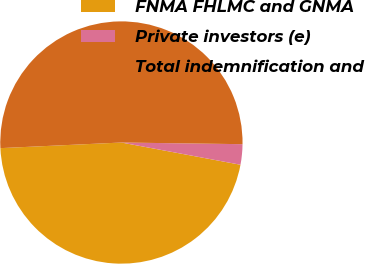Convert chart. <chart><loc_0><loc_0><loc_500><loc_500><pie_chart><fcel>FNMA FHLMC and GNMA<fcel>Private investors (e)<fcel>Total indemnification and<nl><fcel>46.32%<fcel>2.72%<fcel>50.95%<nl></chart> 